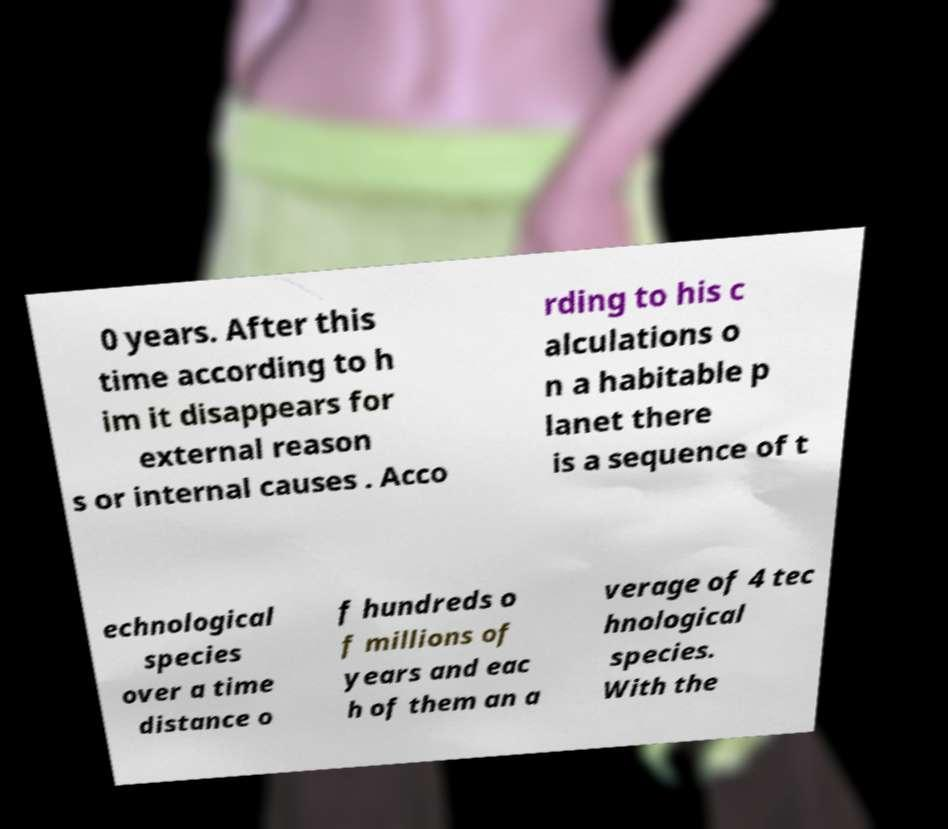I need the written content from this picture converted into text. Can you do that? 0 years. After this time according to h im it disappears for external reason s or internal causes . Acco rding to his c alculations o n a habitable p lanet there is a sequence of t echnological species over a time distance o f hundreds o f millions of years and eac h of them an a verage of 4 tec hnological species. With the 